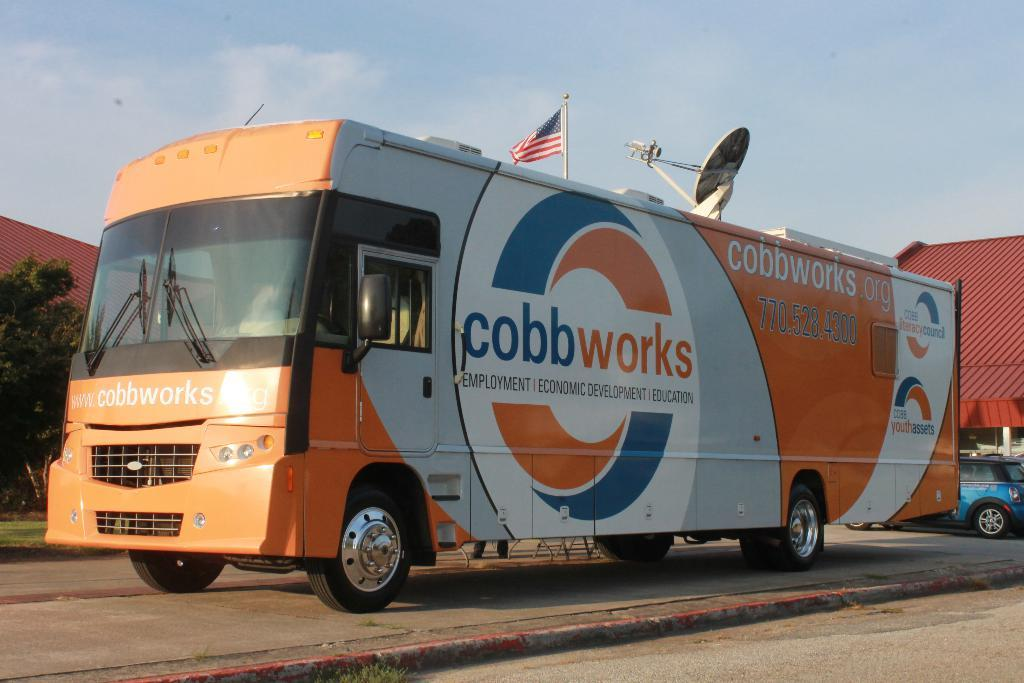What can be seen on the surface in the image? There are vehicles on the surface in the image. What is attached to a pole in the image? There is a flag with a pole in the image. What type of antenna is present in the image? There is a dish antenna in the image. What type of vegetation is visible in the image? There is a tree in the image. What can be seen in the background of the image? There are rooftops and the sky visible in the background of the image. What type of government is depicted in the image? There is no depiction of a government in the image; it features vehicles, a flag, a dish antenna, a tree, rooftops, and the sky. What kind of trouble is the tree causing in the image? There is no trouble caused by the tree in the image; it is simply a tree. 